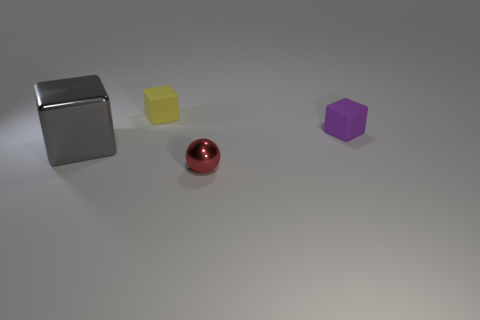Are there any other things that have the same size as the gray metal block?
Provide a short and direct response. No. What color is the metallic object that is the same size as the purple matte cube?
Make the answer very short. Red. There is a rubber thing on the left side of the rubber object that is on the right side of the tiny metallic sphere; what is its color?
Your answer should be compact. Yellow. Do the metal thing in front of the big gray metal thing and the large cube have the same color?
Make the answer very short. No. There is a small object that is on the left side of the shiny thing in front of the shiny object that is to the left of the red object; what shape is it?
Offer a terse response. Cube. How many large gray objects are to the left of the metal thing on the right side of the big shiny cube?
Give a very brief answer. 1. Is the material of the large gray block the same as the yellow object?
Your answer should be very brief. No. How many blocks are left of the cube that is right of the shiny thing to the right of the big block?
Your answer should be very brief. 2. There is a rubber object on the right side of the red shiny sphere; what is its color?
Offer a terse response. Purple. There is a matte object on the right side of the tiny thing that is to the left of the tiny metal thing; what is its shape?
Offer a terse response. Cube. 